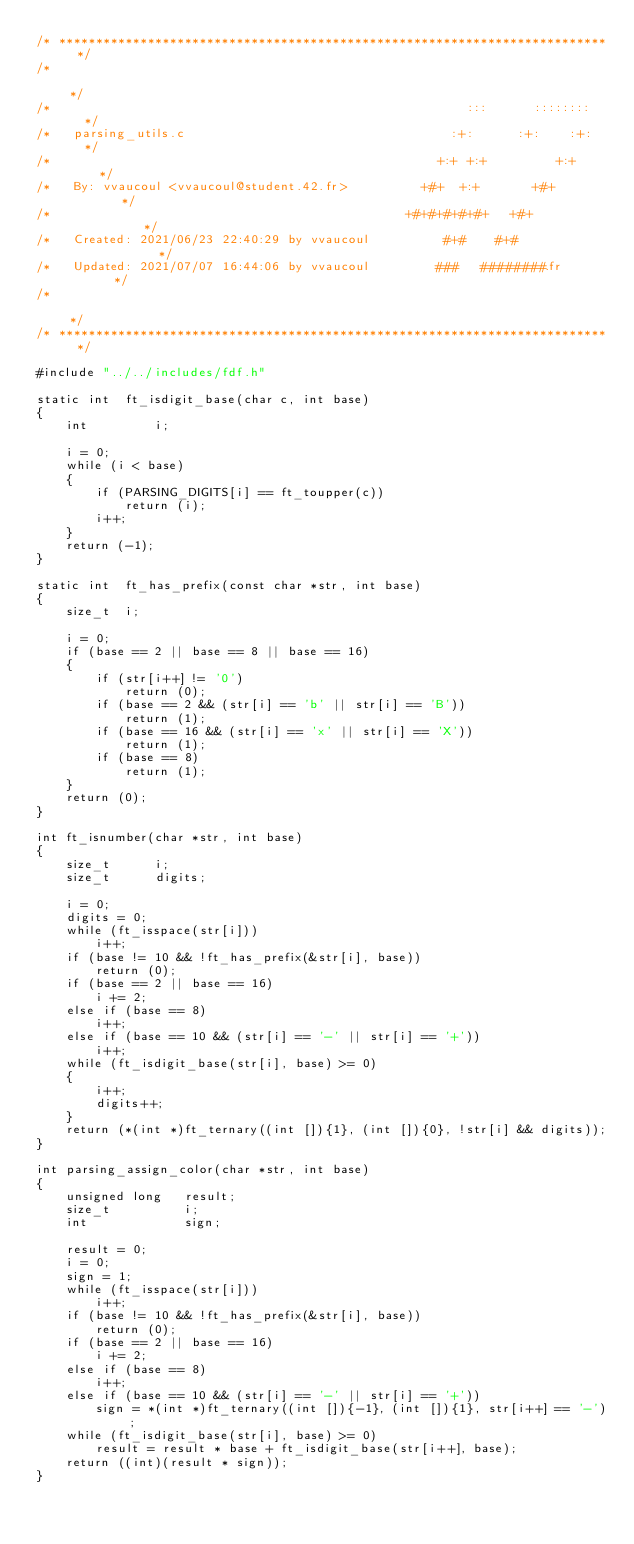<code> <loc_0><loc_0><loc_500><loc_500><_C_>/* ************************************************************************** */
/*                                                                            */
/*                                                        :::      ::::::::   */
/*   parsing_utils.c                                    :+:      :+:    :+:   */
/*                                                    +:+ +:+         +:+     */
/*   By: vvaucoul <vvaucoul@student.42.fr>          +#+  +:+       +#+        */
/*                                                +#+#+#+#+#+   +#+           */
/*   Created: 2021/06/23 22:40:29 by vvaucoul          #+#    #+#             */
/*   Updated: 2021/07/07 16:44:06 by vvaucoul         ###   ########.fr       */
/*                                                                            */
/* ************************************************************************** */

#include "../../includes/fdf.h"

static int	ft_isdigit_base(char c, int base)
{
	int			i;

	i = 0;
	while (i < base)
	{
		if (PARSING_DIGITS[i] == ft_toupper(c))
			return (i);
		i++;
	}
	return (-1);
}

static int	ft_has_prefix(const char *str, int base)
{
	size_t	i;

	i = 0;
	if (base == 2 || base == 8 || base == 16)
	{
		if (str[i++] != '0')
			return (0);
		if (base == 2 && (str[i] == 'b' || str[i] == 'B'))
			return (1);
		if (base == 16 && (str[i] == 'x' || str[i] == 'X'))
			return (1);
		if (base == 8)
			return (1);
	}
	return (0);
}

int	ft_isnumber(char *str, int base)
{
	size_t		i;
	size_t		digits;

	i = 0;
	digits = 0;
	while (ft_isspace(str[i]))
		i++;
	if (base != 10 && !ft_has_prefix(&str[i], base))
		return (0);
	if (base == 2 || base == 16)
		i += 2;
	else if (base == 8)
		i++;
	else if (base == 10 && (str[i] == '-' || str[i] == '+'))
		i++;
	while (ft_isdigit_base(str[i], base) >= 0)
	{
		i++;
		digits++;
	}
	return (*(int *)ft_ternary((int []){1}, (int []){0}, !str[i] && digits));
}

int	parsing_assign_color(char *str, int base)
{
	unsigned long	result;
	size_t			i;
	int				sign;

	result = 0;
	i = 0;
	sign = 1;
	while (ft_isspace(str[i]))
		i++;
	if (base != 10 && !ft_has_prefix(&str[i], base))
		return (0);
	if (base == 2 || base == 16)
		i += 2;
	else if (base == 8)
		i++;
	else if (base == 10 && (str[i] == '-' || str[i] == '+'))
		sign = *(int *)ft_ternary((int []){-1}, (int []){1}, str[i++] == '-');
	while (ft_isdigit_base(str[i], base) >= 0)
		result = result * base + ft_isdigit_base(str[i++], base);
	return ((int)(result * sign));
}
</code> 